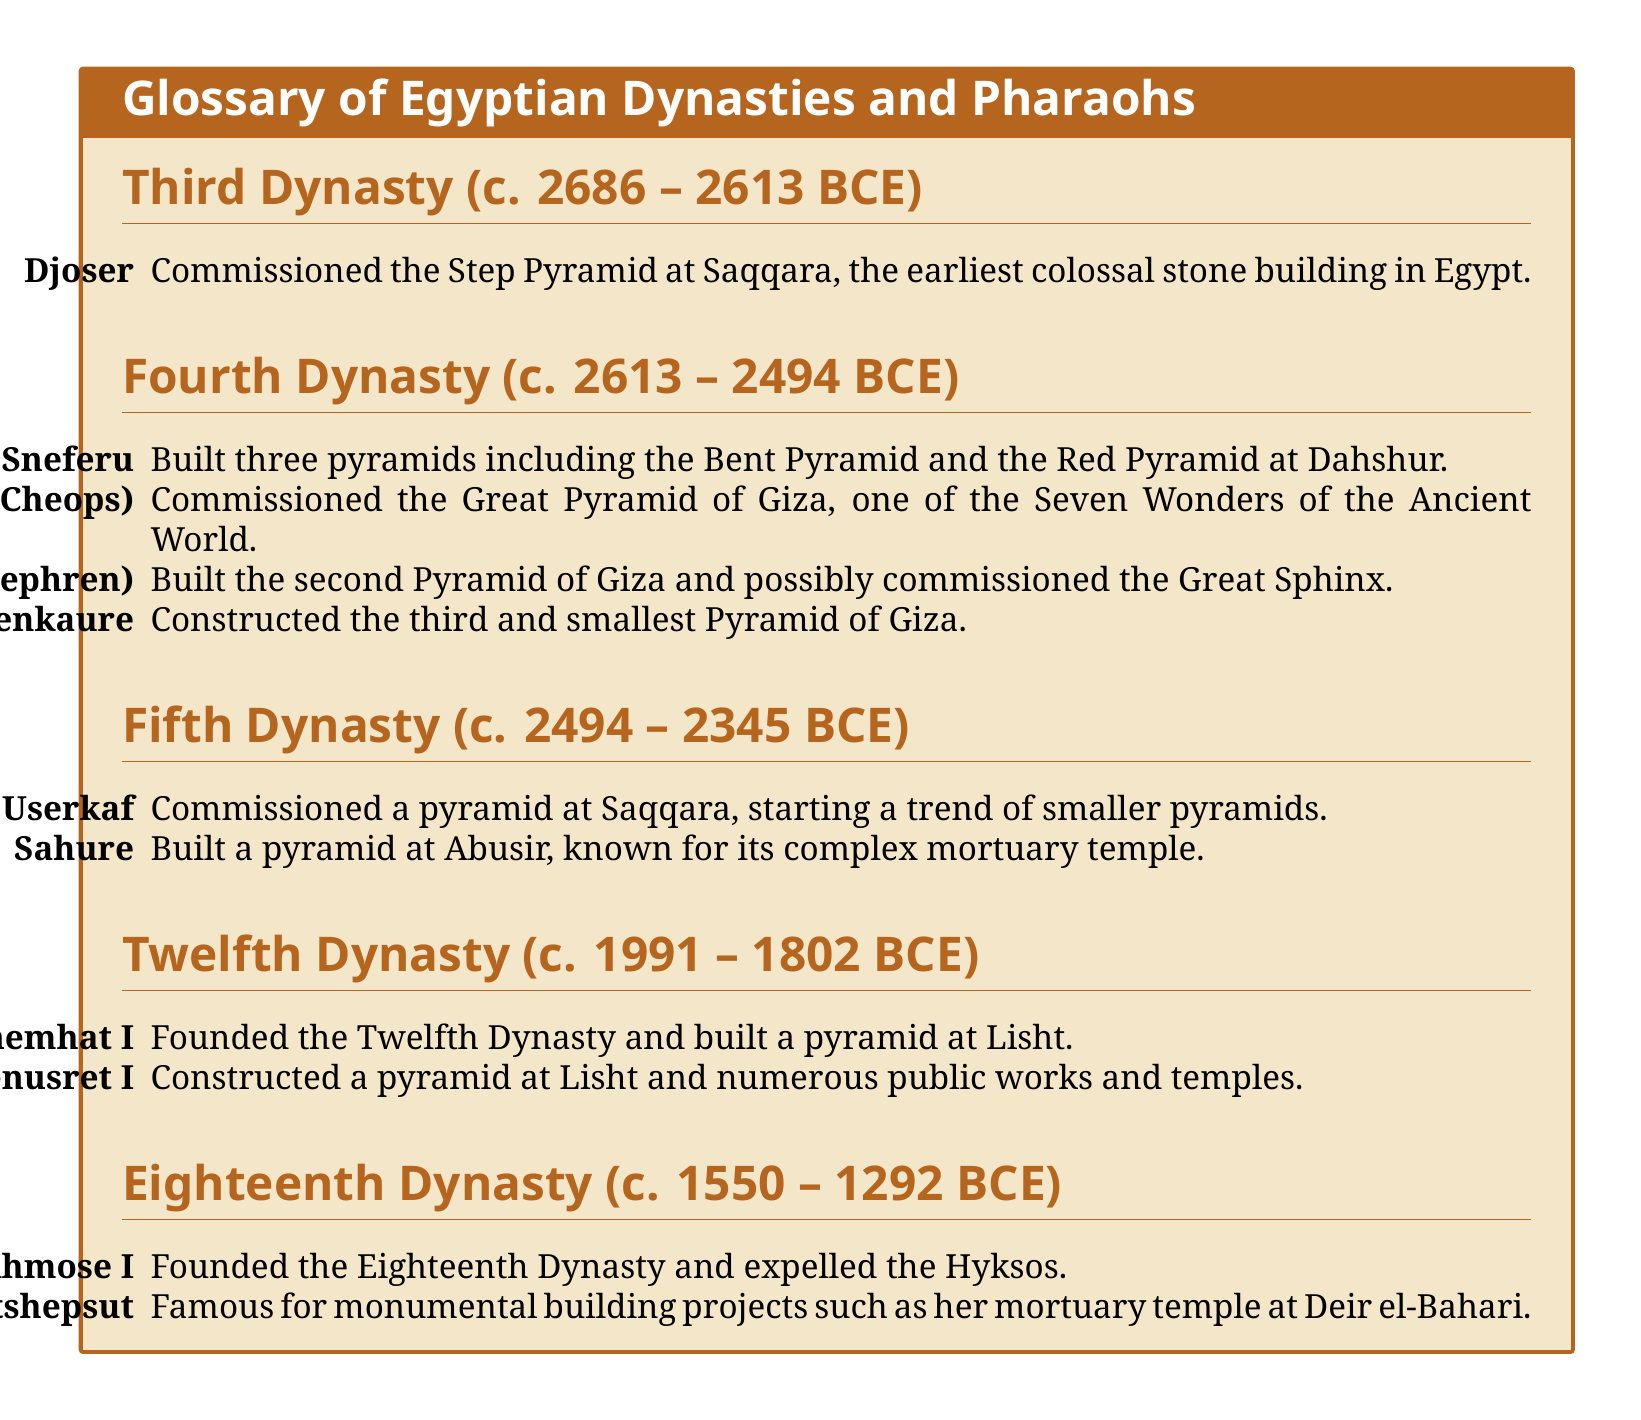What is the time period of the Third Dynasty? The Third Dynasty lasted from approximately 2686 to 2613 BCE, as noted in the document.
Answer: c. 2686 – 2613 BCE Who commissioned the Great Pyramid of Giza? The document states that Khufu, also known as Cheops, commissioned the Great Pyramid of Giza.
Answer: Khufu (Cheops) Which pharaoh is known for the Bent Pyramid? According to the document, Sneferu is known for building the Bent Pyramid.
Answer: Sneferu What is significant about the Twelfth Dynasty? The Twelfth Dynasty is notable for being founded by Amenemhat I and includes significant pyramid construction.
Answer: Founded the Twelfth Dynasty What is the time span of the Eighteenth Dynasty? The Eighteenth Dynasty is from around 1550 to 1292 BCE, as provided in the document.
Answer: c. 1550 – 1292 BCE Which pharaoh expelled the Hyksos? Ahmose I expelled the Hyksos, as mentioned in the document.
Answer: Ahmose I What is a characteristic of Userkaf's pyramid? The document indicates that Userkaf's pyramid at Saqqara began a trend of smaller pyramids.
Answer: Smaller pyramids Which dynasty is associated with Hatshepsut? The document specifies that Hatshepsut is associated with the Eighteenth Dynasty.
Answer: Eighteenth Dynasty What is a notable structure built by Senusret I? Senusret I is noted for constructing a pyramid at Lisht in the document.
Answer: Pyramid at Lisht 